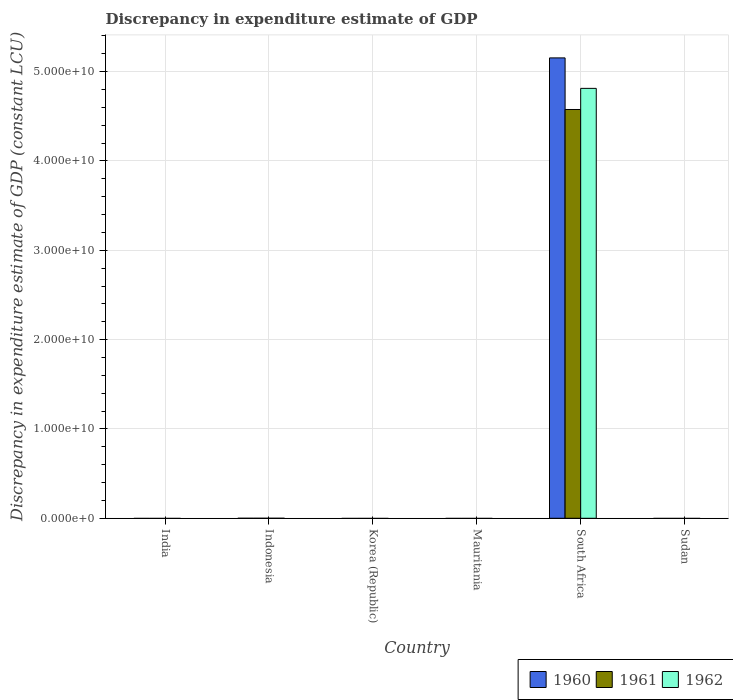How many different coloured bars are there?
Give a very brief answer. 3. Are the number of bars on each tick of the X-axis equal?
Make the answer very short. No. Across all countries, what is the maximum discrepancy in expenditure estimate of GDP in 1961?
Offer a very short reply. 4.58e+1. In which country was the discrepancy in expenditure estimate of GDP in 1960 maximum?
Provide a short and direct response. South Africa. What is the total discrepancy in expenditure estimate of GDP in 1960 in the graph?
Keep it short and to the point. 5.15e+1. What is the average discrepancy in expenditure estimate of GDP in 1961 per country?
Offer a terse response. 7.63e+09. What is the difference between the discrepancy in expenditure estimate of GDP of/in 1962 and discrepancy in expenditure estimate of GDP of/in 1960 in South Africa?
Offer a very short reply. -3.41e+09. What is the difference between the highest and the lowest discrepancy in expenditure estimate of GDP in 1962?
Give a very brief answer. 4.81e+1. In how many countries, is the discrepancy in expenditure estimate of GDP in 1962 greater than the average discrepancy in expenditure estimate of GDP in 1962 taken over all countries?
Give a very brief answer. 1. Is it the case that in every country, the sum of the discrepancy in expenditure estimate of GDP in 1962 and discrepancy in expenditure estimate of GDP in 1961 is greater than the discrepancy in expenditure estimate of GDP in 1960?
Offer a very short reply. No. How many bars are there?
Keep it short and to the point. 3. Are all the bars in the graph horizontal?
Keep it short and to the point. No. What is the difference between two consecutive major ticks on the Y-axis?
Provide a short and direct response. 1.00e+1. Does the graph contain grids?
Your response must be concise. Yes. What is the title of the graph?
Give a very brief answer. Discrepancy in expenditure estimate of GDP. What is the label or title of the X-axis?
Your response must be concise. Country. What is the label or title of the Y-axis?
Your answer should be very brief. Discrepancy in expenditure estimate of GDP (constant LCU). What is the Discrepancy in expenditure estimate of GDP (constant LCU) of 1961 in India?
Provide a short and direct response. 0. What is the Discrepancy in expenditure estimate of GDP (constant LCU) in 1960 in Indonesia?
Give a very brief answer. 0. What is the Discrepancy in expenditure estimate of GDP (constant LCU) in 1962 in Indonesia?
Give a very brief answer. 0. What is the Discrepancy in expenditure estimate of GDP (constant LCU) of 1962 in Korea (Republic)?
Make the answer very short. 0. What is the Discrepancy in expenditure estimate of GDP (constant LCU) in 1962 in Mauritania?
Give a very brief answer. 0. What is the Discrepancy in expenditure estimate of GDP (constant LCU) in 1960 in South Africa?
Offer a terse response. 5.15e+1. What is the Discrepancy in expenditure estimate of GDP (constant LCU) of 1961 in South Africa?
Your answer should be compact. 4.58e+1. What is the Discrepancy in expenditure estimate of GDP (constant LCU) in 1962 in South Africa?
Your answer should be very brief. 4.81e+1. What is the Discrepancy in expenditure estimate of GDP (constant LCU) in 1961 in Sudan?
Provide a short and direct response. 0. What is the Discrepancy in expenditure estimate of GDP (constant LCU) in 1962 in Sudan?
Keep it short and to the point. 0. Across all countries, what is the maximum Discrepancy in expenditure estimate of GDP (constant LCU) of 1960?
Your answer should be very brief. 5.15e+1. Across all countries, what is the maximum Discrepancy in expenditure estimate of GDP (constant LCU) of 1961?
Give a very brief answer. 4.58e+1. Across all countries, what is the maximum Discrepancy in expenditure estimate of GDP (constant LCU) of 1962?
Offer a terse response. 4.81e+1. Across all countries, what is the minimum Discrepancy in expenditure estimate of GDP (constant LCU) in 1960?
Your answer should be very brief. 0. Across all countries, what is the minimum Discrepancy in expenditure estimate of GDP (constant LCU) in 1961?
Give a very brief answer. 0. What is the total Discrepancy in expenditure estimate of GDP (constant LCU) of 1960 in the graph?
Offer a terse response. 5.15e+1. What is the total Discrepancy in expenditure estimate of GDP (constant LCU) of 1961 in the graph?
Your response must be concise. 4.58e+1. What is the total Discrepancy in expenditure estimate of GDP (constant LCU) of 1962 in the graph?
Give a very brief answer. 4.81e+1. What is the average Discrepancy in expenditure estimate of GDP (constant LCU) in 1960 per country?
Your response must be concise. 8.59e+09. What is the average Discrepancy in expenditure estimate of GDP (constant LCU) in 1961 per country?
Offer a terse response. 7.63e+09. What is the average Discrepancy in expenditure estimate of GDP (constant LCU) of 1962 per country?
Provide a short and direct response. 8.02e+09. What is the difference between the Discrepancy in expenditure estimate of GDP (constant LCU) of 1960 and Discrepancy in expenditure estimate of GDP (constant LCU) of 1961 in South Africa?
Your response must be concise. 5.78e+09. What is the difference between the Discrepancy in expenditure estimate of GDP (constant LCU) of 1960 and Discrepancy in expenditure estimate of GDP (constant LCU) of 1962 in South Africa?
Your answer should be compact. 3.41e+09. What is the difference between the Discrepancy in expenditure estimate of GDP (constant LCU) of 1961 and Discrepancy in expenditure estimate of GDP (constant LCU) of 1962 in South Africa?
Make the answer very short. -2.37e+09. What is the difference between the highest and the lowest Discrepancy in expenditure estimate of GDP (constant LCU) of 1960?
Offer a very short reply. 5.15e+1. What is the difference between the highest and the lowest Discrepancy in expenditure estimate of GDP (constant LCU) of 1961?
Provide a short and direct response. 4.58e+1. What is the difference between the highest and the lowest Discrepancy in expenditure estimate of GDP (constant LCU) in 1962?
Provide a short and direct response. 4.81e+1. 